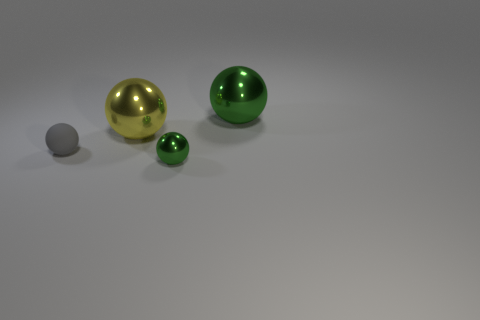Subtract all purple spheres. Subtract all red cylinders. How many spheres are left? 4 Add 1 small gray balls. How many objects exist? 5 Add 4 red rubber blocks. How many red rubber blocks exist? 4 Subtract 0 cyan cubes. How many objects are left? 4 Subtract all large green balls. Subtract all tiny balls. How many objects are left? 1 Add 4 big metal objects. How many big metal objects are left? 6 